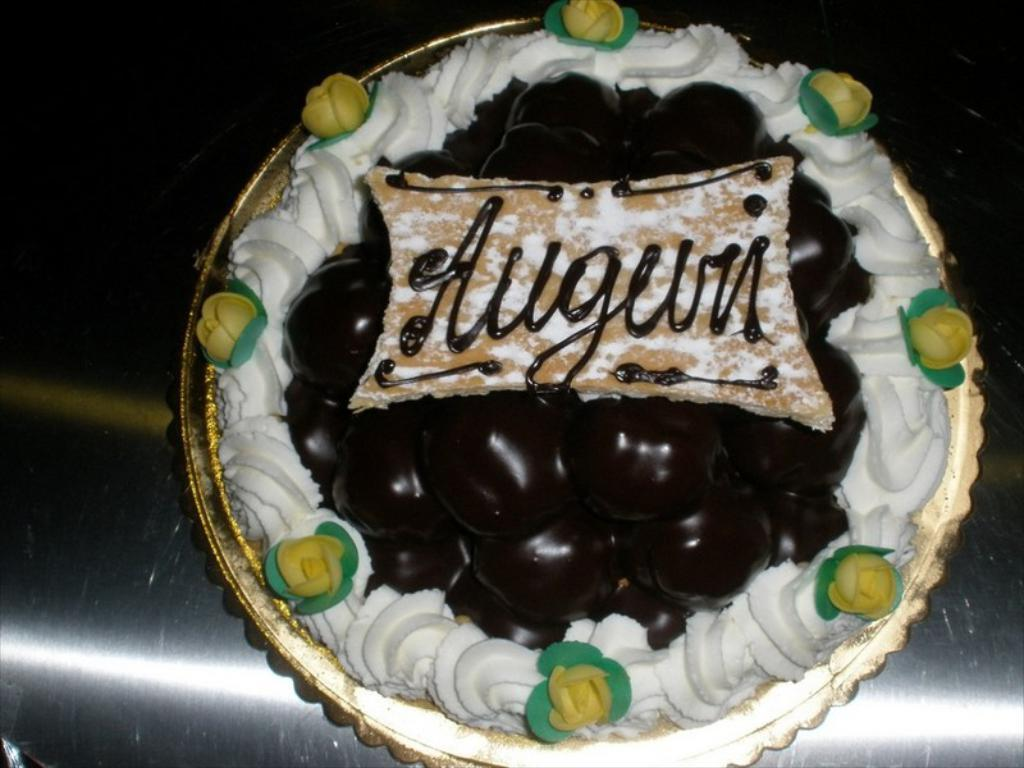What is the main subject of the image? The main subject of the image is a cake. What is the cake placed on? The cake is on a metal surface. Is there any writing or design on the cake? Yes, there is text on the cake. What type of ball is being used to decorate the cake in the image? There is no ball present on the cake or in the image. 